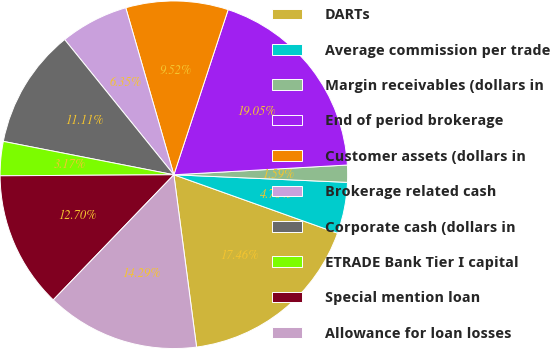Convert chart to OTSL. <chart><loc_0><loc_0><loc_500><loc_500><pie_chart><fcel>DARTs<fcel>Average commission per trade<fcel>Margin receivables (dollars in<fcel>End of period brokerage<fcel>Customer assets (dollars in<fcel>Brokerage related cash<fcel>Corporate cash (dollars in<fcel>ETRADE Bank Tier I capital<fcel>Special mention loan<fcel>Allowance for loan losses<nl><fcel>17.46%<fcel>4.76%<fcel>1.59%<fcel>19.05%<fcel>9.52%<fcel>6.35%<fcel>11.11%<fcel>3.17%<fcel>12.7%<fcel>14.29%<nl></chart> 